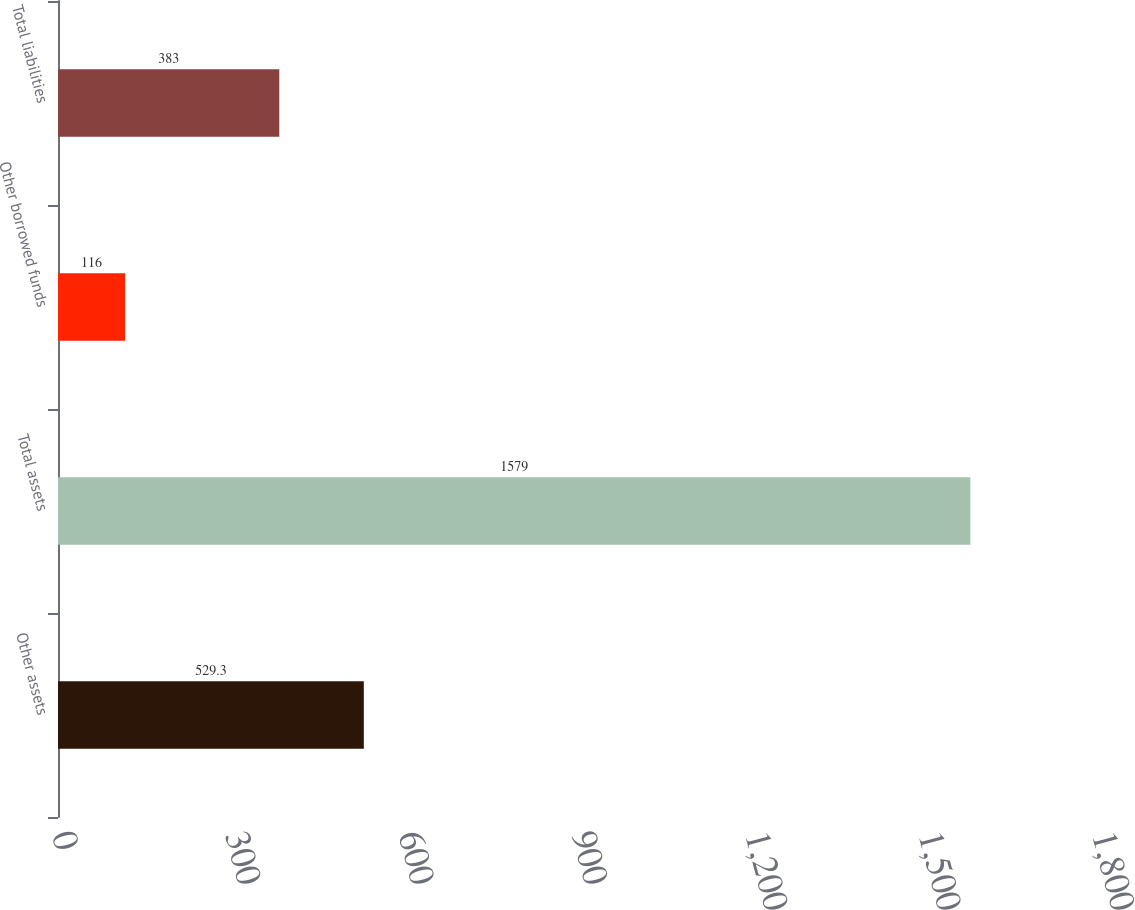<chart> <loc_0><loc_0><loc_500><loc_500><bar_chart><fcel>Other assets<fcel>Total assets<fcel>Other borrowed funds<fcel>Total liabilities<nl><fcel>529.3<fcel>1579<fcel>116<fcel>383<nl></chart> 